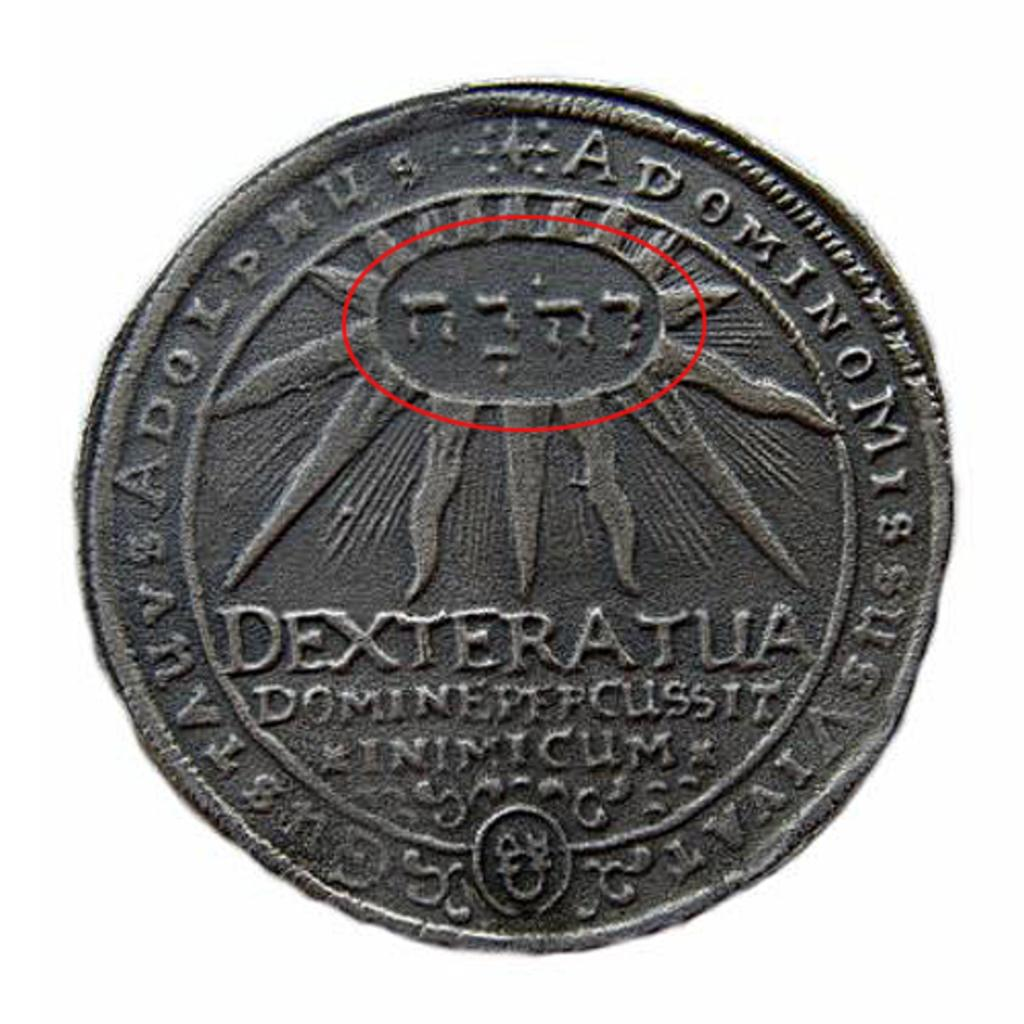<image>
Render a clear and concise summary of the photo. a coin that says 'dexteratua' on it along with other writings 